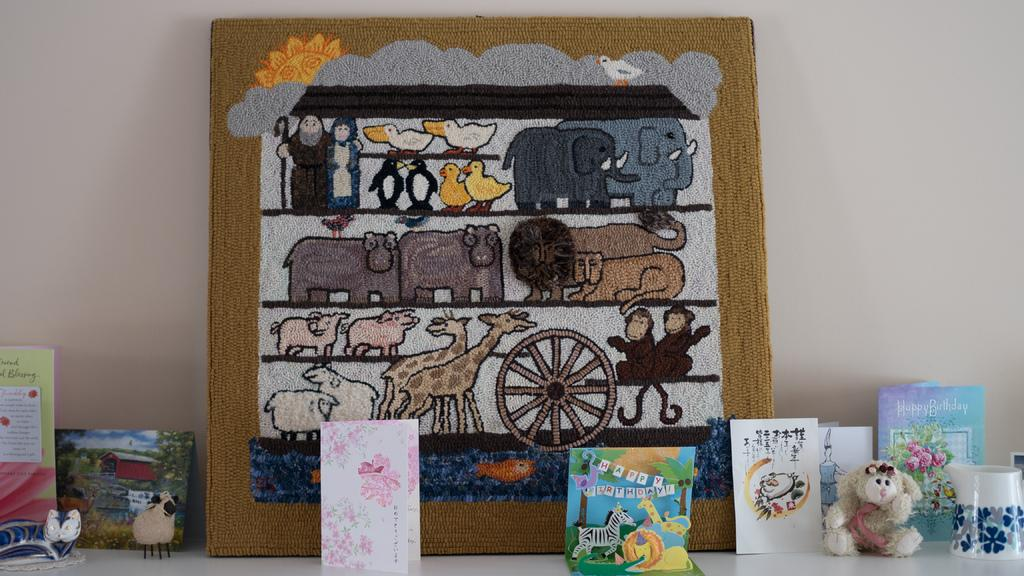What is the main object in the image? There is a frame in the image. What other items can be seen in the frame? There are cards and toys in the image. What is the container for holding liquids in the image? There is a cup in the image. Where are the objects placed in the image? The objects are placed on a table. What can be seen in the background of the image? There is a wall in the background of the image. What type of fowl can be seen in the image? There is no fowl present in the image. What property is being sold in the image? There is no property being sold in the image. 